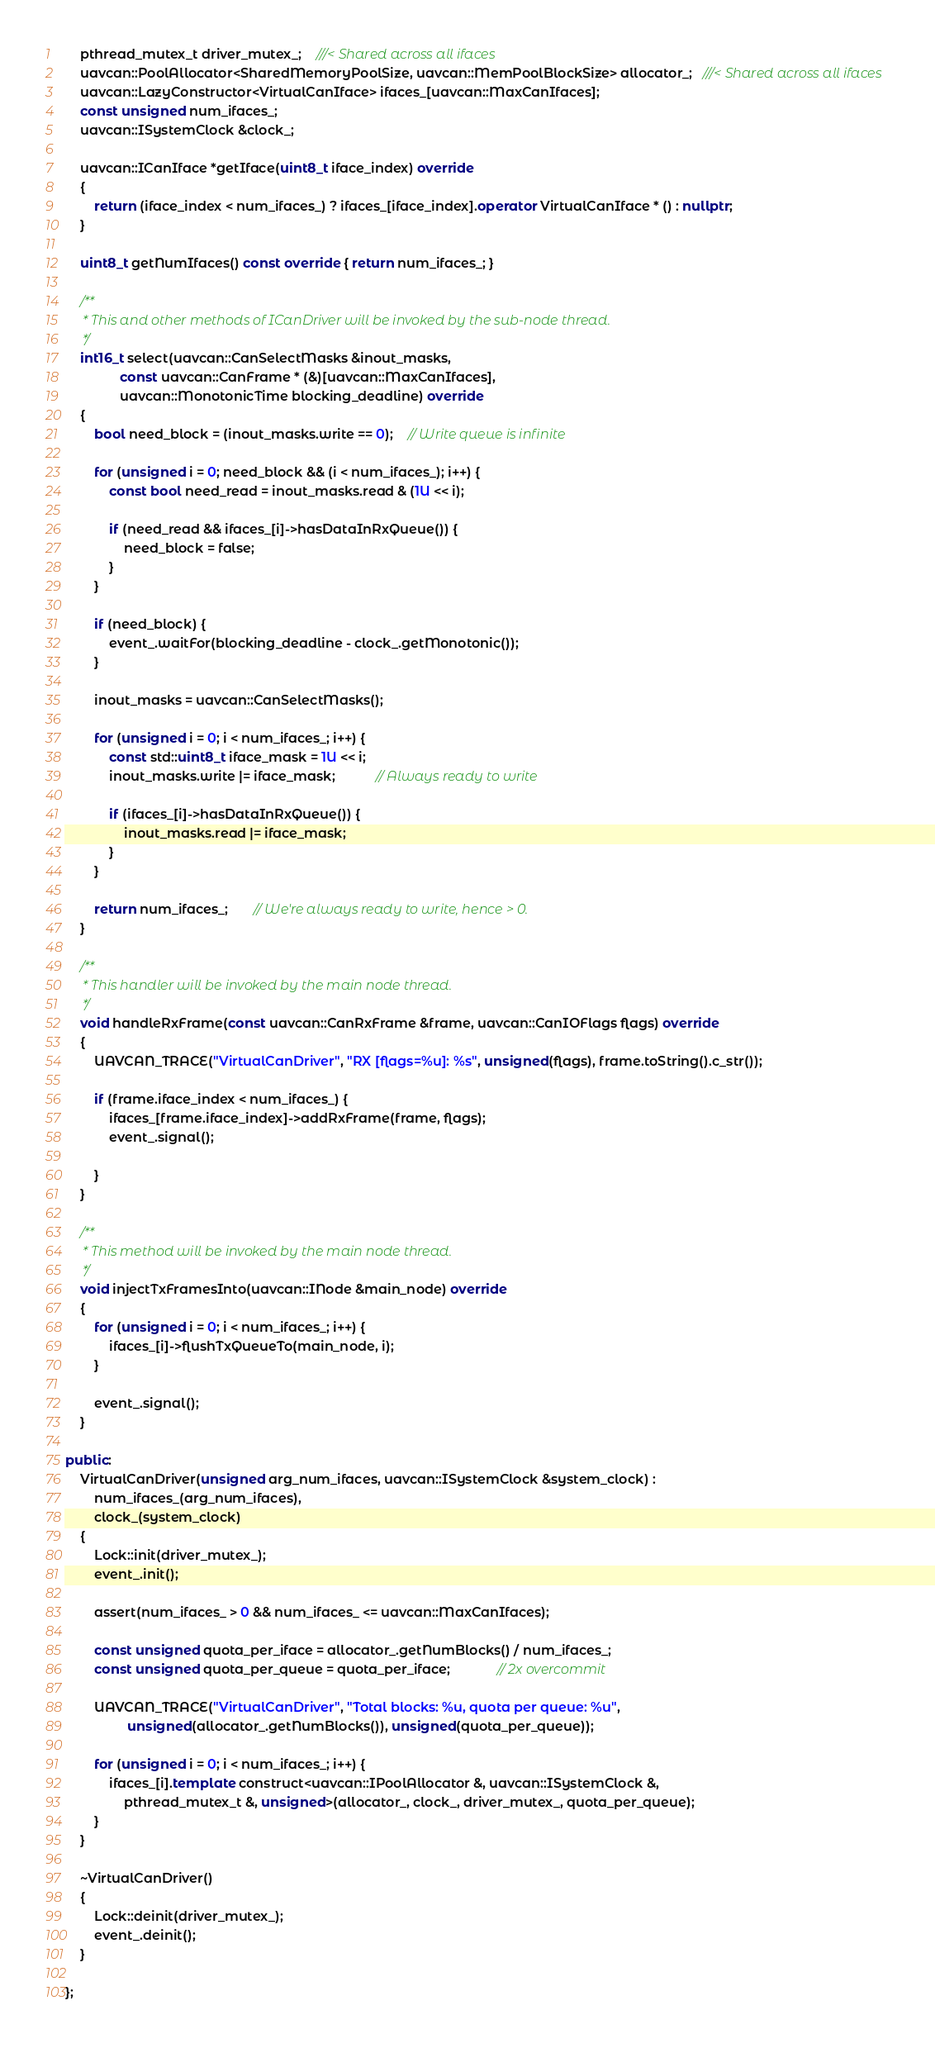<code> <loc_0><loc_0><loc_500><loc_500><_C++_>	pthread_mutex_t driver_mutex_;    ///< Shared across all ifaces
	uavcan::PoolAllocator<SharedMemoryPoolSize, uavcan::MemPoolBlockSize> allocator_;   ///< Shared across all ifaces
	uavcan::LazyConstructor<VirtualCanIface> ifaces_[uavcan::MaxCanIfaces];
	const unsigned num_ifaces_;
	uavcan::ISystemClock &clock_;

	uavcan::ICanIface *getIface(uint8_t iface_index) override
	{
		return (iface_index < num_ifaces_) ? ifaces_[iface_index].operator VirtualCanIface * () : nullptr;
	}

	uint8_t getNumIfaces() const override { return num_ifaces_; }

	/**
	 * This and other methods of ICanDriver will be invoked by the sub-node thread.
	 */
	int16_t select(uavcan::CanSelectMasks &inout_masks,
		       const uavcan::CanFrame * (&)[uavcan::MaxCanIfaces],
		       uavcan::MonotonicTime blocking_deadline) override
	{
		bool need_block = (inout_masks.write == 0);    // Write queue is infinite

		for (unsigned i = 0; need_block && (i < num_ifaces_); i++) {
			const bool need_read = inout_masks.read & (1U << i);

			if (need_read && ifaces_[i]->hasDataInRxQueue()) {
				need_block = false;
			}
		}

		if (need_block) {
			event_.waitFor(blocking_deadline - clock_.getMonotonic());
		}

		inout_masks = uavcan::CanSelectMasks();

		for (unsigned i = 0; i < num_ifaces_; i++) {
			const std::uint8_t iface_mask = 1U << i;
			inout_masks.write |= iface_mask;           // Always ready to write

			if (ifaces_[i]->hasDataInRxQueue()) {
				inout_masks.read |= iface_mask;
			}
		}

		return num_ifaces_;       // We're always ready to write, hence > 0.
	}

	/**
	 * This handler will be invoked by the main node thread.
	 */
	void handleRxFrame(const uavcan::CanRxFrame &frame, uavcan::CanIOFlags flags) override
	{
		UAVCAN_TRACE("VirtualCanDriver", "RX [flags=%u]: %s", unsigned(flags), frame.toString().c_str());

		if (frame.iface_index < num_ifaces_) {
			ifaces_[frame.iface_index]->addRxFrame(frame, flags);
			event_.signal();

		}
	}

	/**
	 * This method will be invoked by the main node thread.
	 */
	void injectTxFramesInto(uavcan::INode &main_node) override
	{
		for (unsigned i = 0; i < num_ifaces_; i++) {
			ifaces_[i]->flushTxQueueTo(main_node, i);
		}

		event_.signal();
	}

public:
	VirtualCanDriver(unsigned arg_num_ifaces, uavcan::ISystemClock &system_clock) :
		num_ifaces_(arg_num_ifaces),
		clock_(system_clock)
	{
		Lock::init(driver_mutex_);
		event_.init();

		assert(num_ifaces_ > 0 && num_ifaces_ <= uavcan::MaxCanIfaces);

		const unsigned quota_per_iface = allocator_.getNumBlocks() / num_ifaces_;
		const unsigned quota_per_queue = quota_per_iface;             // 2x overcommit

		UAVCAN_TRACE("VirtualCanDriver", "Total blocks: %u, quota per queue: %u",
			     unsigned(allocator_.getNumBlocks()), unsigned(quota_per_queue));

		for (unsigned i = 0; i < num_ifaces_; i++) {
			ifaces_[i].template construct<uavcan::IPoolAllocator &, uavcan::ISystemClock &,
				pthread_mutex_t &, unsigned>(allocator_, clock_, driver_mutex_, quota_per_queue);
		}
	}

	~VirtualCanDriver()
	{
		Lock::deinit(driver_mutex_);
		event_.deinit();
	}

};
</code> 